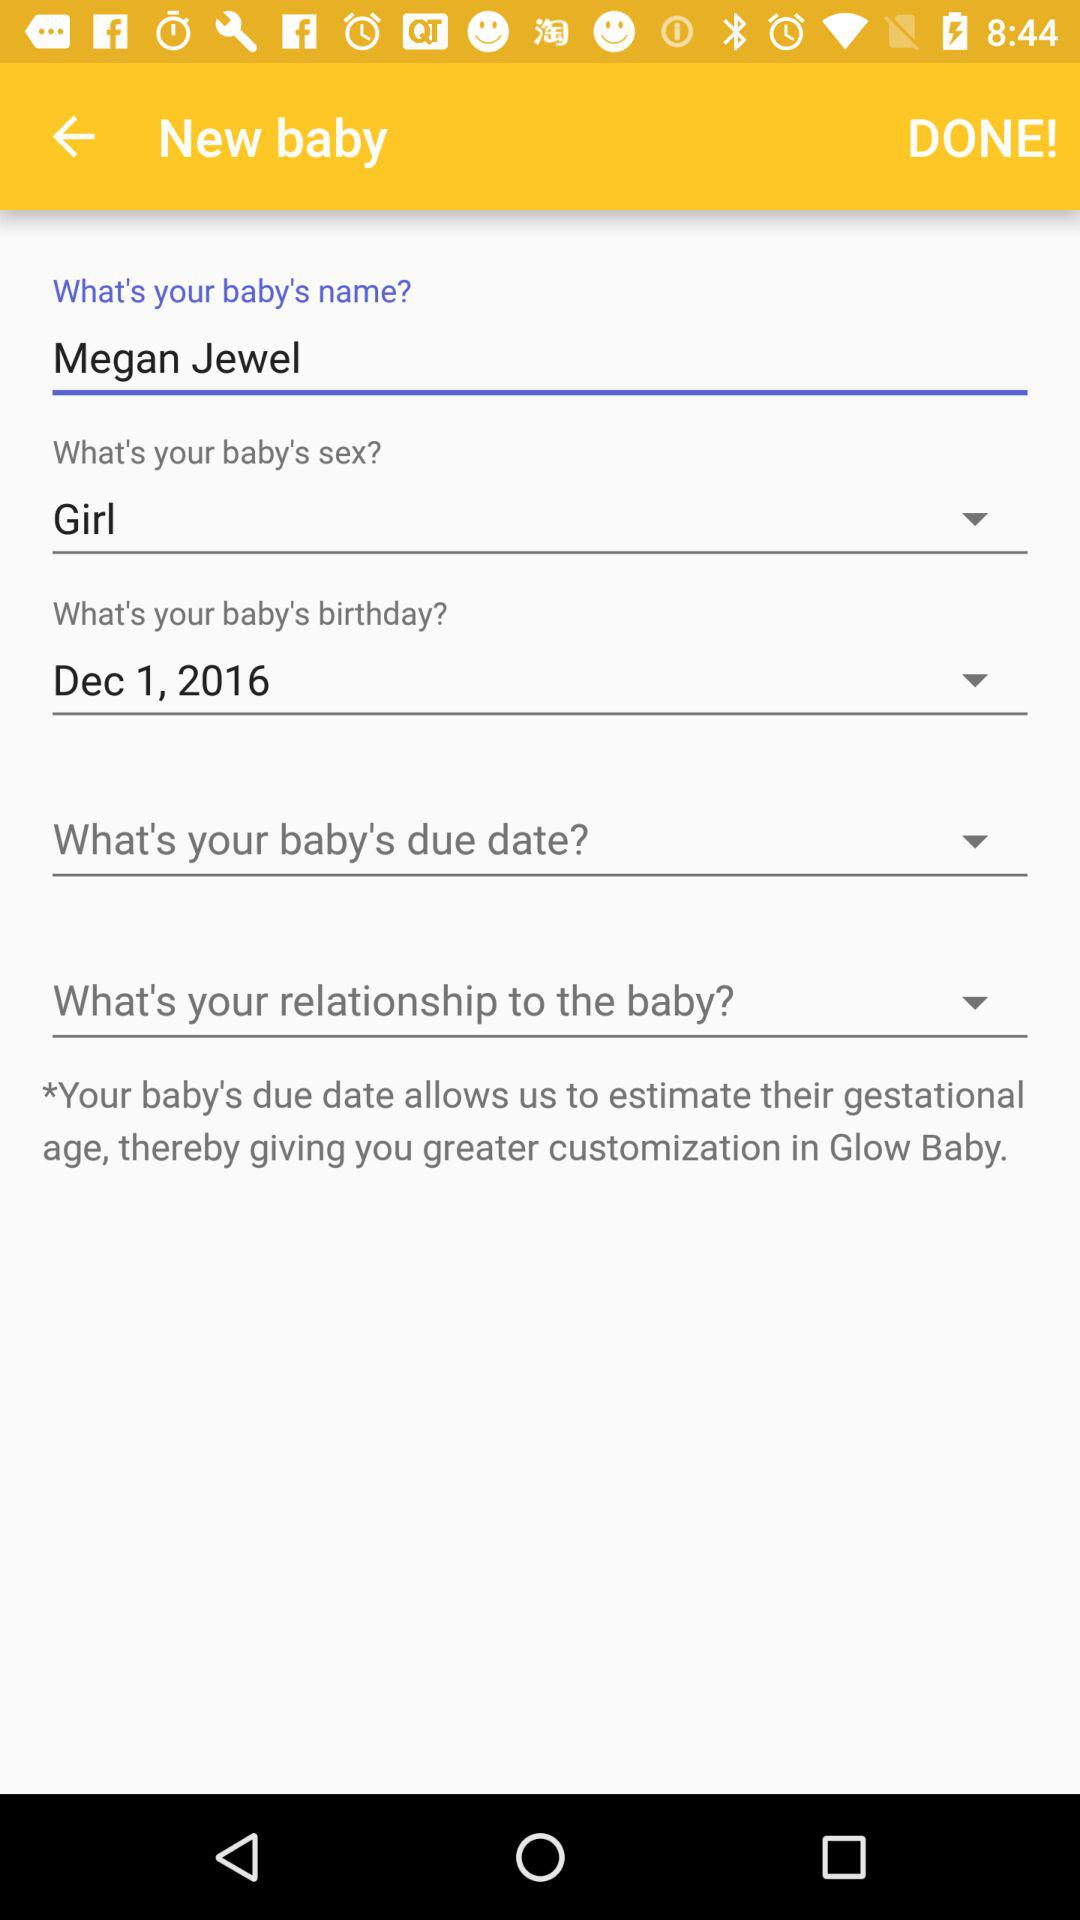What is the baby's name? The baby's name is Megan Jewel. 